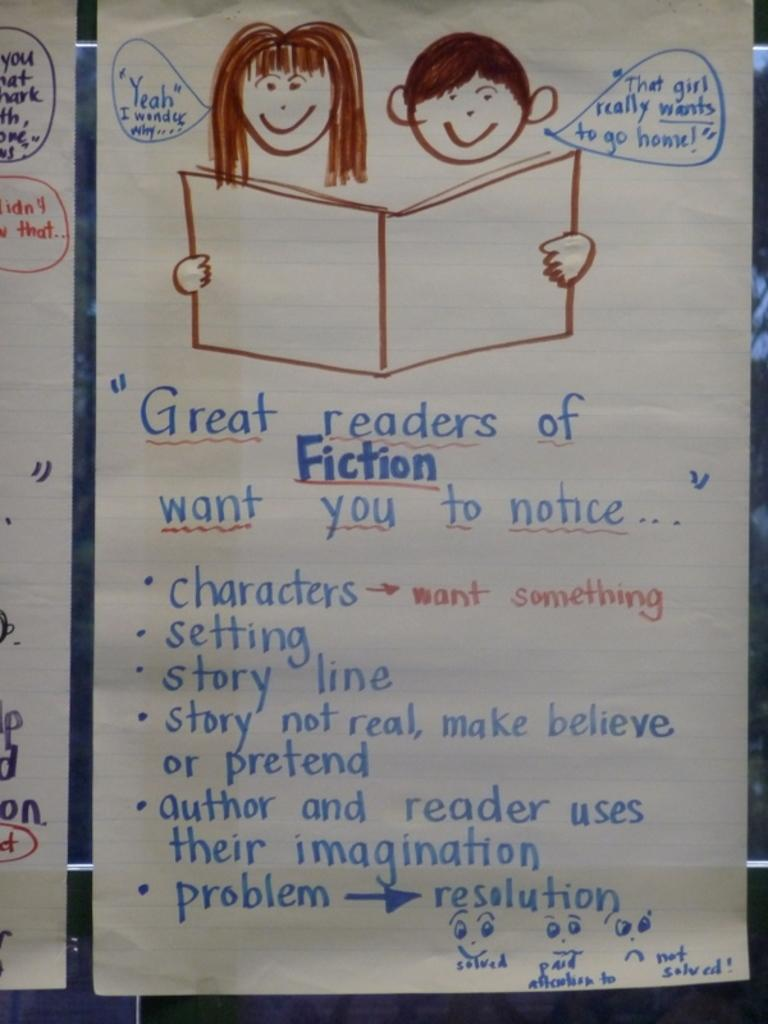What is depicted on the paper in the image? There are pictures on a paper in the image. What else can be found on the paper besides the pictures? There is text on the paper. What type of lip can be seen on the airplane in the image? There is no airplane or lip present in the image; it only features pictures and text on a paper. 